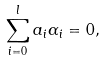Convert formula to latex. <formula><loc_0><loc_0><loc_500><loc_500>\sum _ { i = 0 } ^ { l } a _ { i } \alpha _ { i } = 0 ,</formula> 